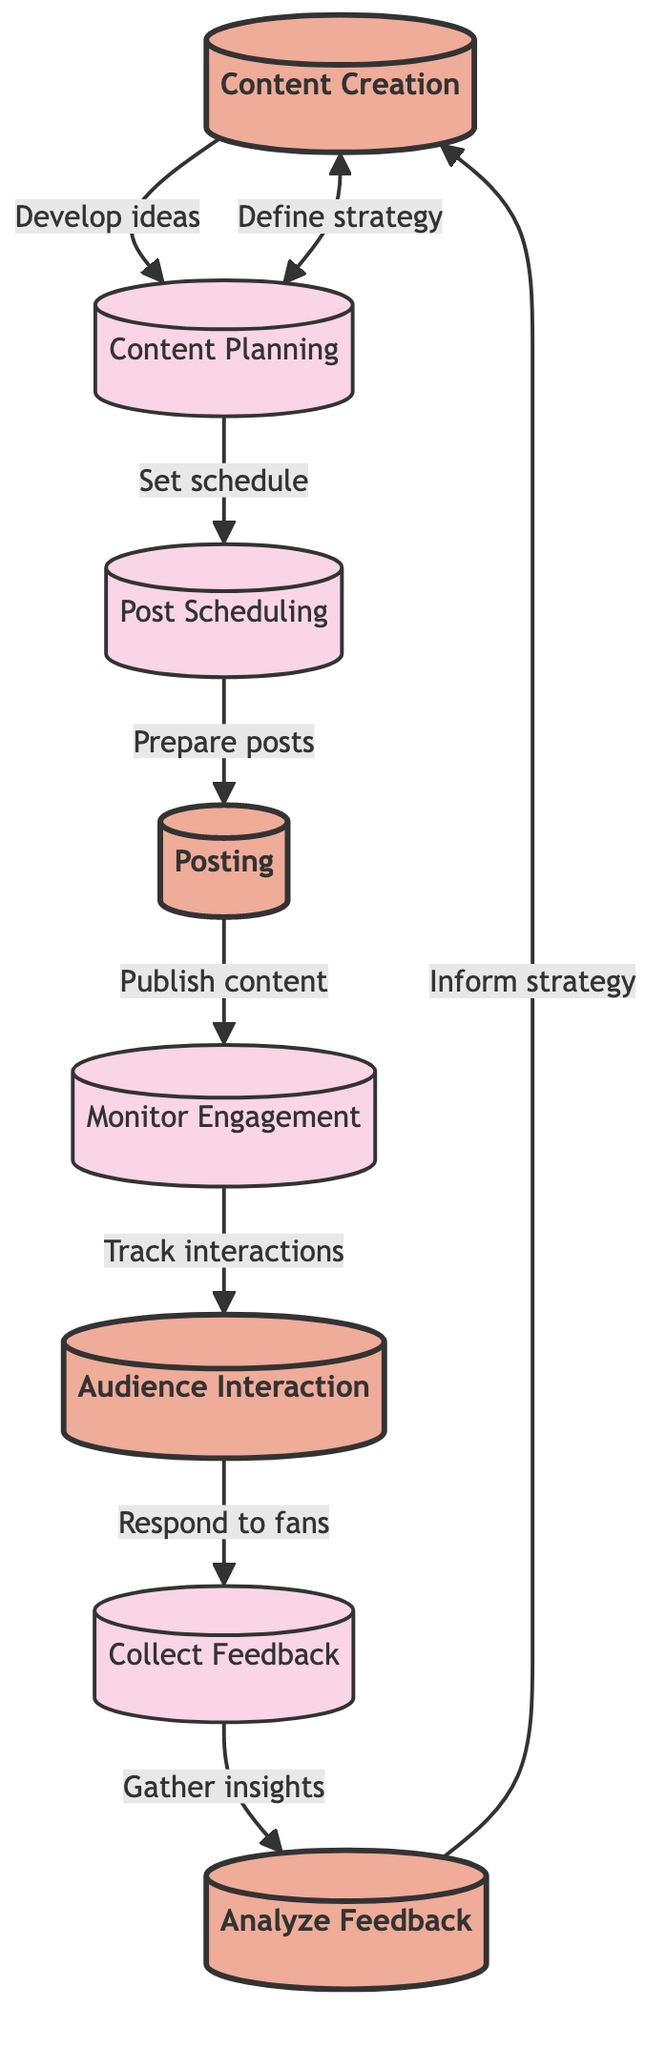What is the first step in the workflow? The first step is indicated at the top of the flowchart. It is the "Content Creation" node, which shows the initial action to be taken.
Answer: Content Creation How many total elements are in the diagram? By counting each individual process node presented in the diagram, we find there are eight distinct elements listed.
Answer: Eight Which elements are directly connected to "Post Scheduling"? The flowchart shows "Content Planning" leads into "Post Scheduling," and "Post Scheduling" connects directly to "Posting." Either of these elements can be mentioned as connected.
Answer: Content Planning, Posting What type of action is linked to the "Audience Interaction" node? The "Audience Interaction" node indicates that the action linked to it is to "Respond to fan comments, messages, and mentions."
Answer: Respond to fan comments, messages, and mentions What happens after "Collect Feedback"? Following the "Collect Feedback" node, the diagram indicates that the next action is to "Analyze Feedback." This shows the progression in the workflow.
Answer: Analyze Feedback How does feedback inform future strategies? The flowchart highlights that feedback is analyzed to "Inform strategy," thus indicating a direct link between the analysis of feedback and future planning.
Answer: Inform strategy Which node follows "Monitor Engagement"? The flowchart specifies that "Audience Interaction" directly follows the "Monitor Engagement" node, showing the flow of actions related to audience engagement.
Answer: Audience Interaction What is the connection between "Analyze Feedback" and "Content Creation"? Upon reviewing the diagram, it is evident that "Analyze Feedback" leads back to "Content Creation," suggesting this is a cyclical process for improving content.
Answer: Content Creation 